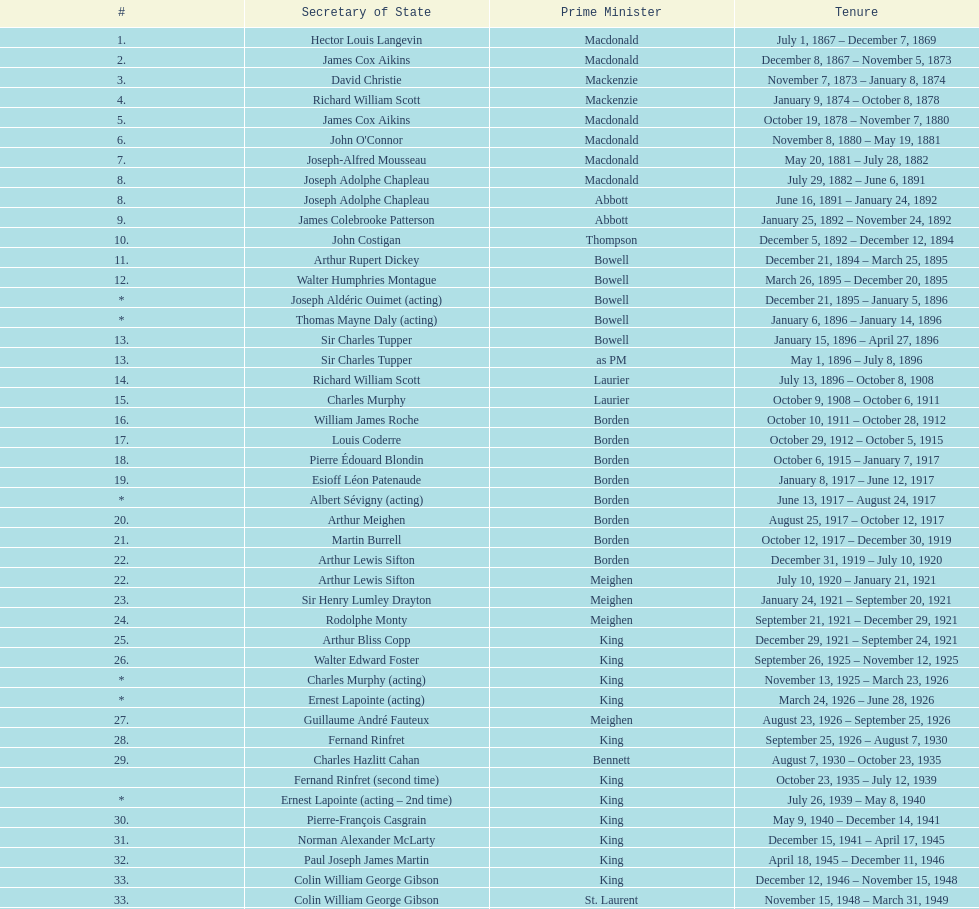After jack pickersgill, who became the secretary of state? Roch Pinard. 